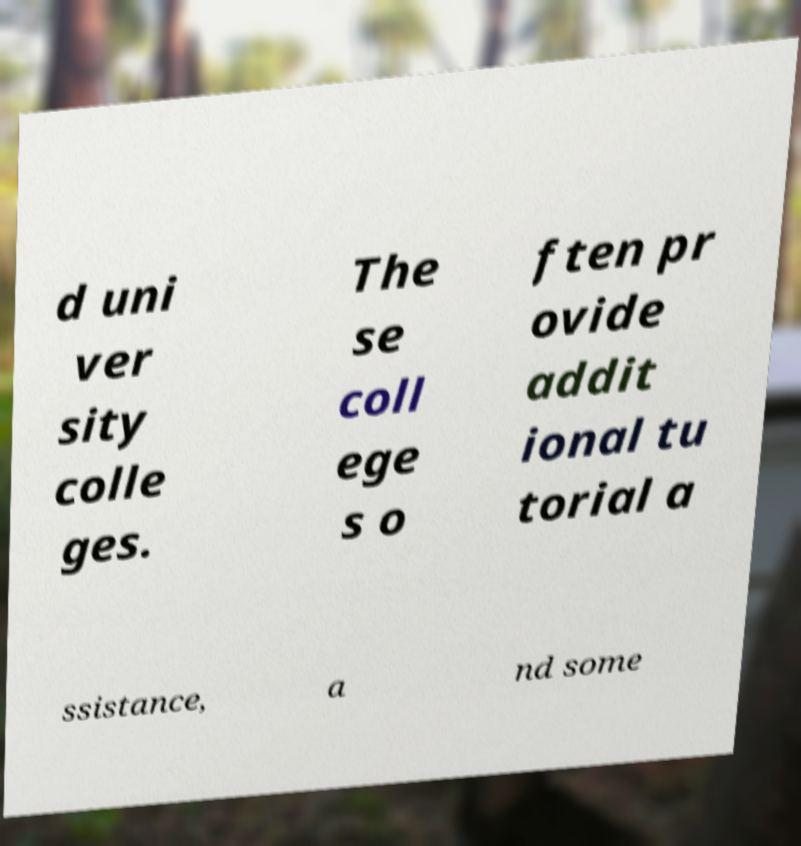Can you read and provide the text displayed in the image?This photo seems to have some interesting text. Can you extract and type it out for me? d uni ver sity colle ges. The se coll ege s o ften pr ovide addit ional tu torial a ssistance, a nd some 